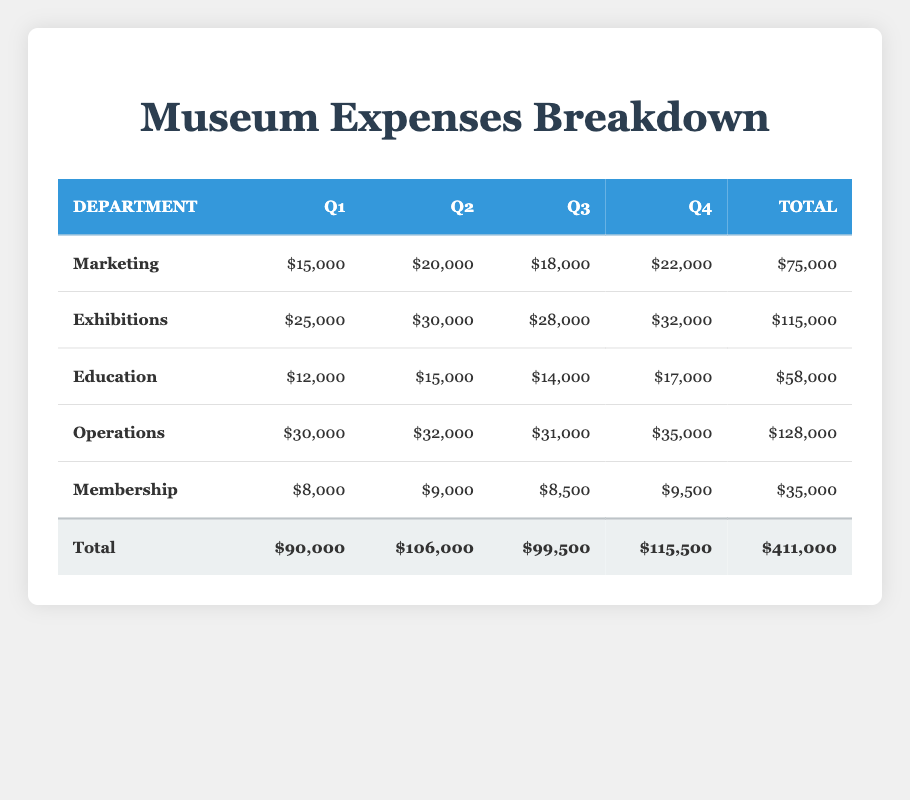What were the total expenses for the Marketing department? To find the total expenses for the Marketing department, we add the expenses from all four quarters: 15000 (Q1) + 20000 (Q2) + 18000 (Q3) + 22000 (Q4) = 75000.
Answer: 75000 Which department had the highest expenses in Q4? By examining the expenses for Q4, we see that Operations spent 35000, Exhibitions spent 32000, Marketing spent 22000, Education spent 17000, and Membership spent 9500. The highest expense is from Operations at 35000.
Answer: Operations Is the total expense for the Education department less than the total expense for Membership? The total expenses for Education is 58000, while the total for Membership is 35000. 58000 is greater than 35000, hence the statement is false.
Answer: No What is the average expense for the Exhibitions department per quarter? To calculate the average expense, we sum the expenses for Exhibitions across all quarters: 25000 + 30000 + 28000 + 32000 = 115000. There are 4 quarters, so the average is 115000 / 4 = 28750.
Answer: 28750 Which department's total expenses were exactly 48000 more than the Membership department's total expenses? Membership total is 35000. To find a total that is 48000 more than this, we add 48000 to 35000 which gives us 83000. The only department close to this total is Operations with 128000. Thus, no department has total expenses exactly 48000 more than Membership.
Answer: No How much did the Marketing department spend in Q3 compared to the average quarterly expense across all departments? In Q3, Marketing spent 18000. The total expenses across all departments in Q3 are 99,500 (from the table), divided by 5 departments gives an average of 19990. The comparison shows that 18000 is less than average.
Answer: 18000 is less What is the total expense for all departments in the second quarter? To find the total expense for the second quarter, we add Q2 expenses from all departments: 20000 (Marketing) + 30000 (Exhibitions) + 15000 (Education) + 32000 (Operations) + 9000 (Membership) = 106000.
Answer: 106000 Did any department have the same expense for Q1 and Q4? Examining Q1 and Q4 expenses, we see Marketing at 15000 (Q1) and 22000 (Q4), Exhibitions at 25000 (Q1) and 32000 (Q4), Education at 12000 (Q1) and 17000 (Q4), Operations at 30000 (Q1) and 35000 (Q4), and Membership at 8000 (Q1) and 9500 (Q4). No expenses match, therefore the answer is no.
Answer: No 